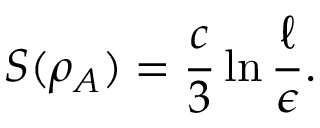<formula> <loc_0><loc_0><loc_500><loc_500>S ( \rho _ { A } ) = \frac { c } { 3 } \ln \frac { \ell } { \epsilon } .</formula> 